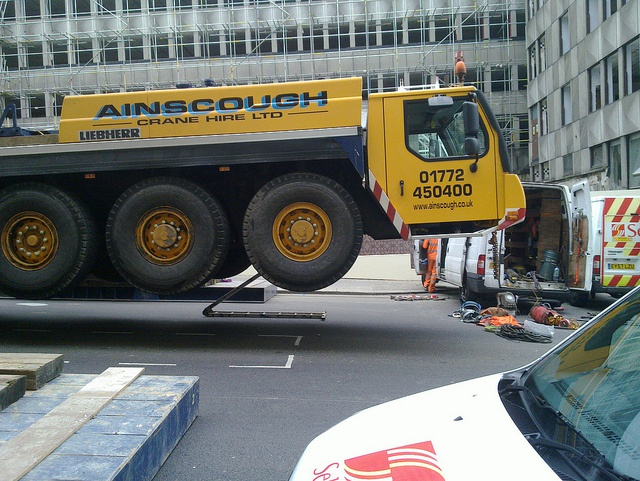Describe the objects in this image and their specific colors. I can see truck in lightblue, black, olive, orange, and gray tones, car in lightblue, white, teal, and blue tones, car in lightblue, black, gray, darkgray, and lightgray tones, and people in lightblue, salmon, and brown tones in this image. 